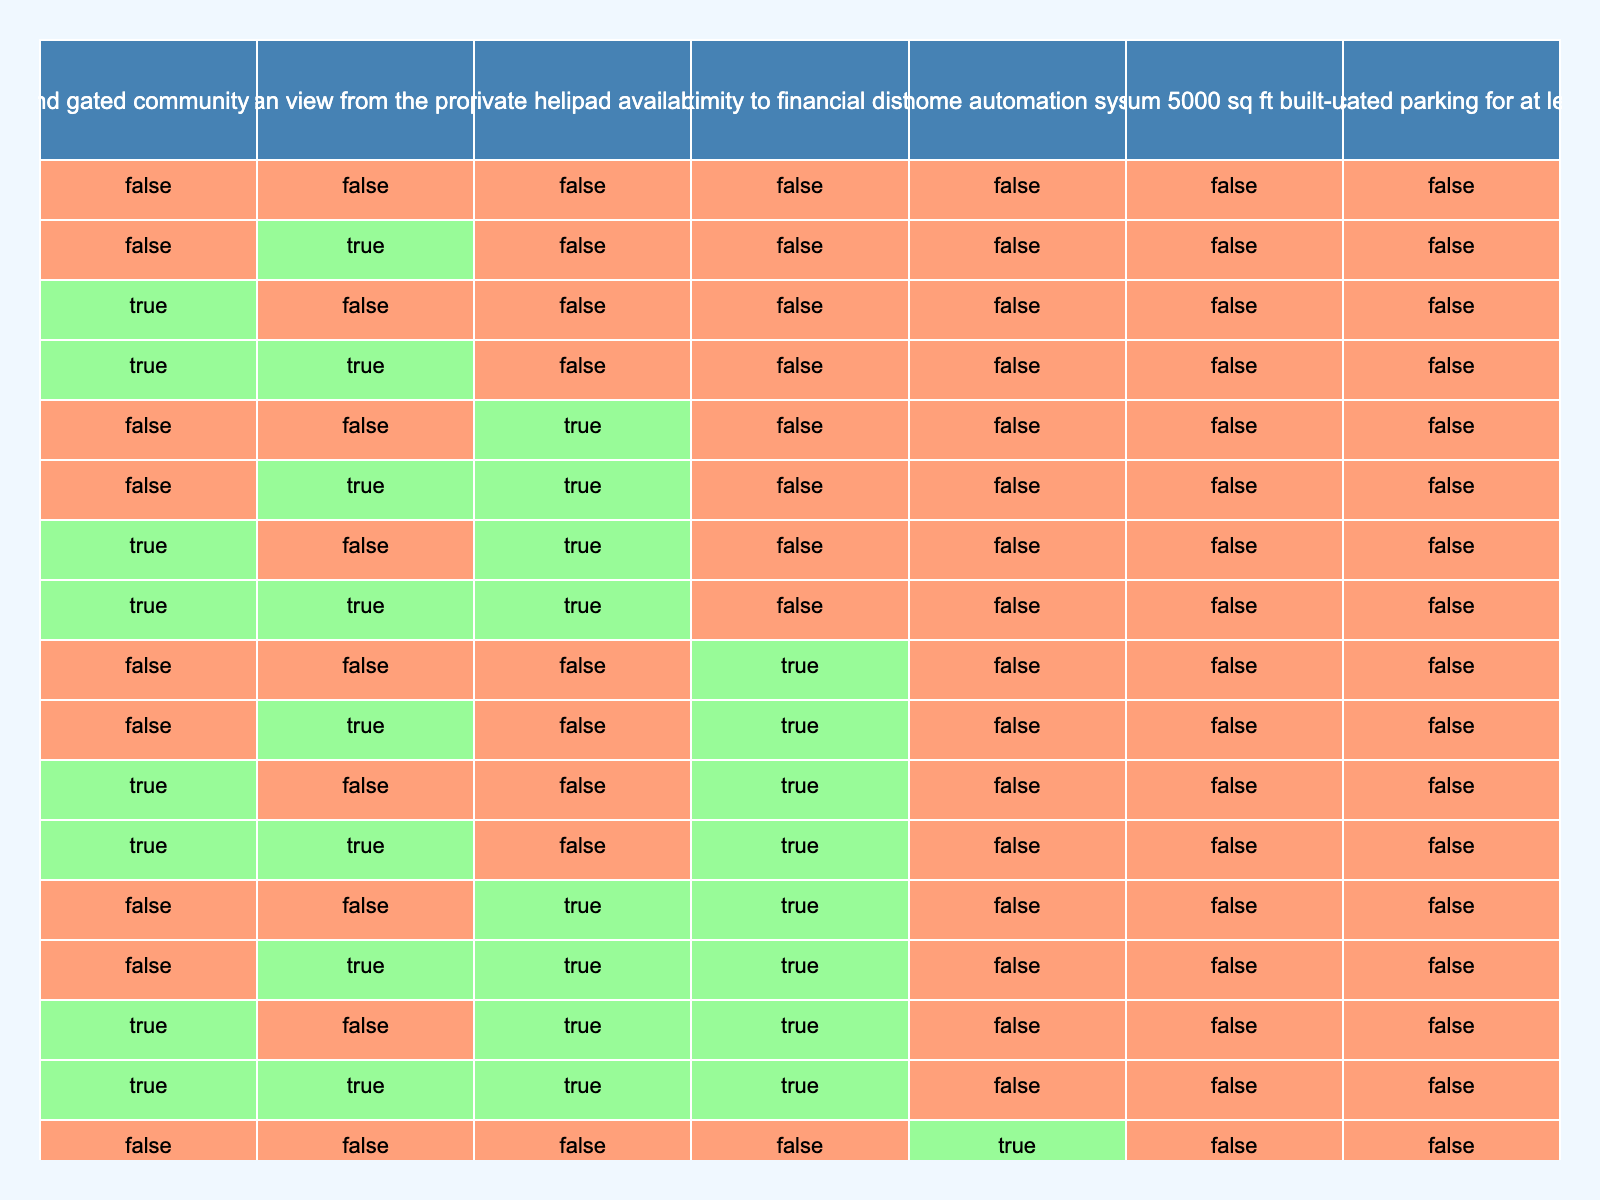What is the total number of propositions listed in the table? There are 7 propositions listed in the table: P, Q, R, S, T, U, V. The count can be obtained by simply counting the rows under the "Proposition" column.
Answer: 7 Is a dedicated parking for at least 3 luxury cars available if the property has a smart home automation system installed? From the table, if T (smart home automation system) is true, there is no implication regarding the dedicated parking (V). Therefore, V could either be true or false regardless of T. Hence, we cannot conclude that dedicated parking is available based solely on T being true.
Answer: No How many propositions correlate with having an ocean view and smart home automation? Propositions Q (ocean view) and T (smart home automation) are two separate properties and can both be true simultaneously. However, based on the table alone, they are independent and the count of related propositions is still two.
Answer: 2 If a property is located in a high-end gated community and has a minimum built-up area of 5000 sq ft, is it guaranteed to have a private helipad? The propositions P (high-end gated community) and U (minimum built-up area) do not imply the availability of R (private helipad). Thus, even if both P and U are true, it does not provide enough evidence to confirm that R is true.
Answer: No What is the condition under which a property has all the luxury considerations? For a property to have all luxury considerations represented in the table (P, Q, R, S, T, U, V), all propositions need to be true simultaneously. This means that for the final combination, there should be no false values.
Answer: All true Is there any scenario when a property could offer both an ocean view and proximity to the financial district without a private helipad? Yes, considering propositions Q (ocean view) and S (proximity to financial district), it is possible to have both of these true (yes), while simultaneously having R (private helipad) be false. This indicates that any combination of true and false statements could lead to such a scenario.
Answer: Yes What proposition is guaranteed when a property lacks proximity to the financial district? If proposition S (proximity to financial district) is false, there is no guarantee regarding any of the other propositions (P, Q, R, T, U, V). Each proposition's status remains independent and can either be true or false.
Answer: None Which proposition implies the largest physical space requirement? Proposition U (minimum 5000 sq ft built-up area) is the only proposition that specifies a space requirement, implying the largest area. All other propositions do not relate to space specifically.
Answer: U 